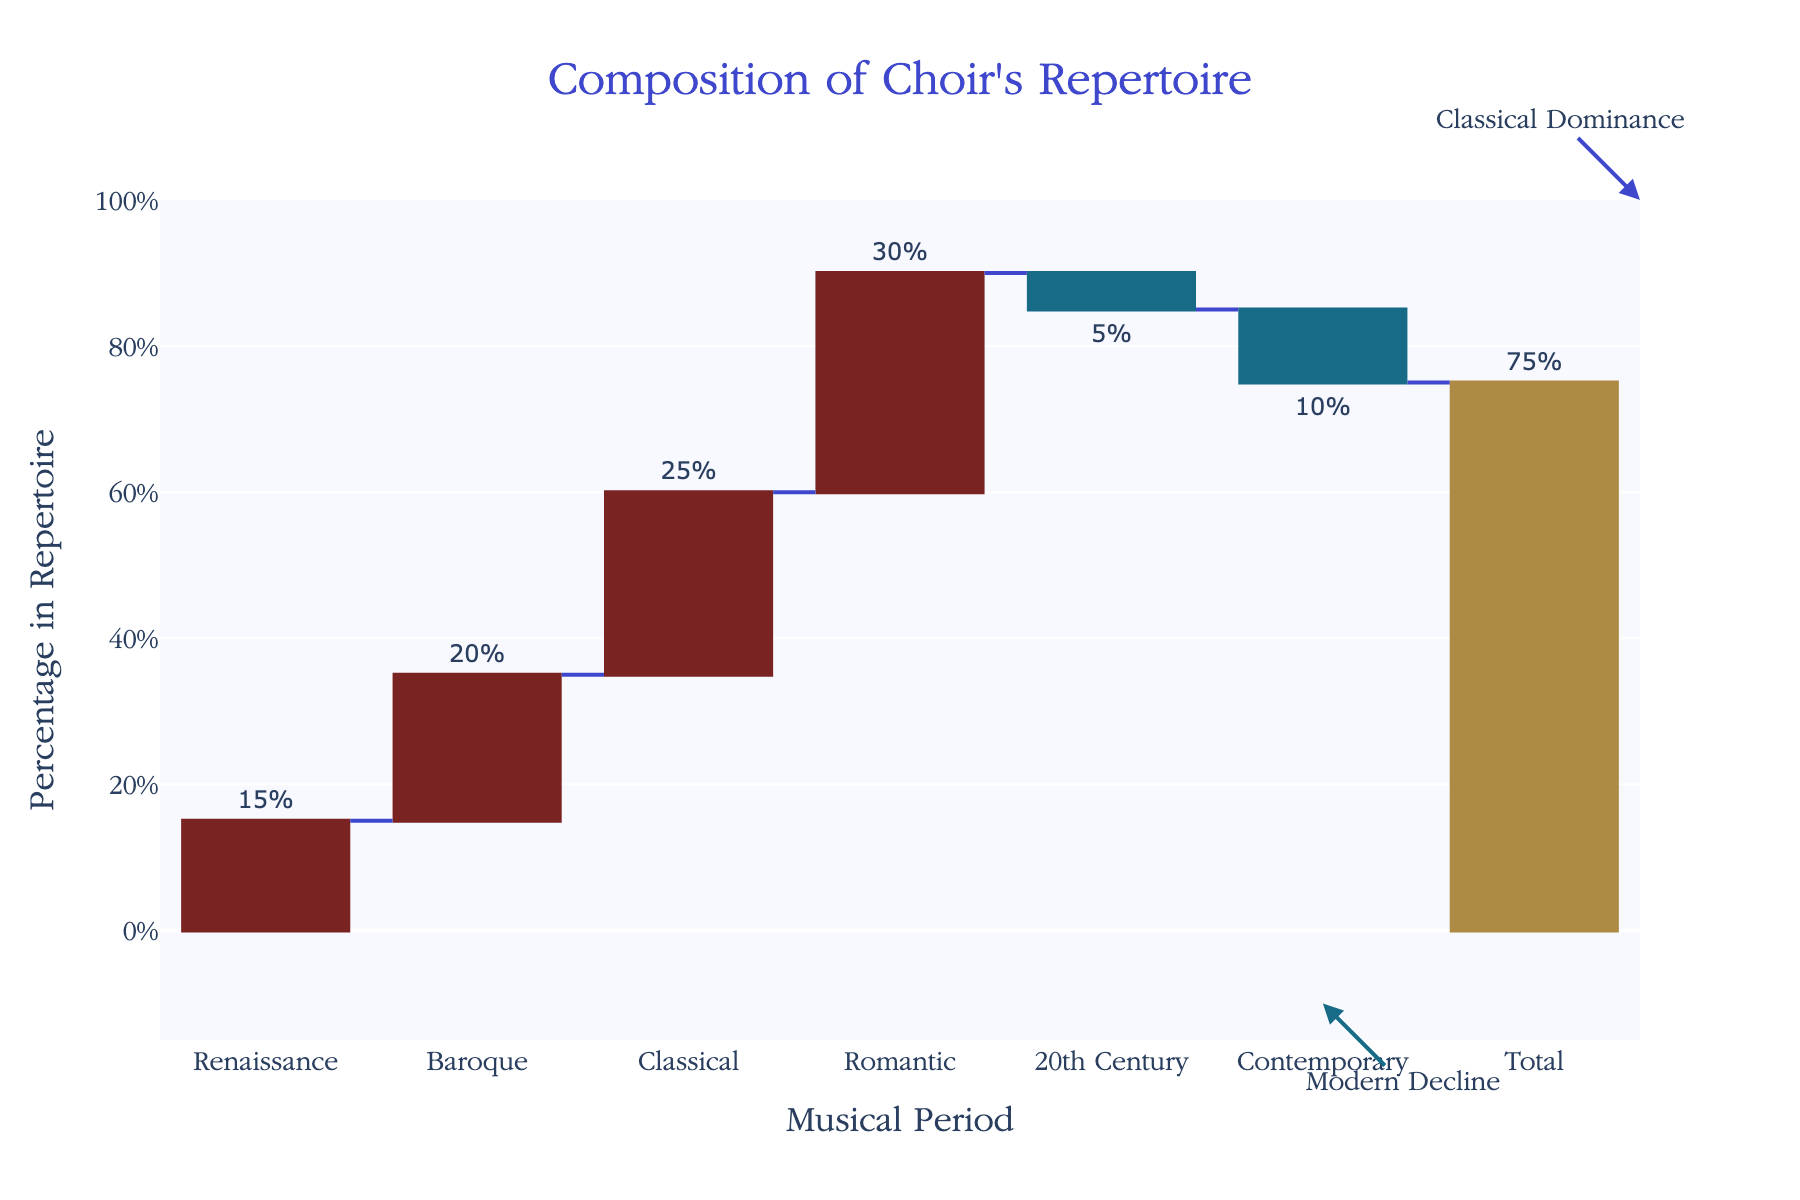How many periods are represented in the choir's repertoire chart? The x-axis lists the musical periods represented, which are: Renaissance, Baroque, Classical, Romantic, 20th Century, and Contemporary. Counting these, we have 6 periods.
Answer: 6 What is the percentage of the choir's repertoire from the Classical period? Read the y-value associated with the "Classical" period bar, which is 25%.
Answer: 25% What's the total percentage covered by pieces from the Romantic and Baroque periods? Add the percentages for the Romantic (30%) and Baroque (20%) periods. 30 + 20 = 50
Answer: 50% Which period has the smallest percentage in the choir's repertoire? Compare the y-values of the bars. The "Contemporary" period has the smallest percentage with -10%.
Answer: Contemporary How does the percentage of the Renaissance period compare to the Baroque period? Check the y-values: Renaissance is at 15%, and Baroque is at 20%. Comparison shows that the Renaissance period is 5% less than the Baroque period.
Answer: 5% less than Baroque What is the net contribution of pieces from the 20th Century and Contemporary periods? Sum the percentages of 20th Century (-5%) and Contemporary (-10%) periods. -5 + (-10) = -15%
Answer: -15% How does the percentage of the Romantic period compare to the total percentage? The y-value for the Romantic period (30%) and the total percentage (75%). The Romantic period contributes 30 out of the total 75, so it accounts for 40% of the total.
Answer: 40% What is indicated by the "Total" bar in the figure? The "Total" bar aggregates all the values from each period to show the overall total percentage, which is 75%.
Answer: 75% What is the significance of the annotations "Classical Dominance" and "Modern Decline"? The annotation "Classical Dominance" near the top indicates that the Classical period is highly represented (25%). The "Modern Decline" near the bottom denotes the negative percentages for the 20th Century (-5%) and Contemporary (-10%).
Answer: Classical high, Modern decline 